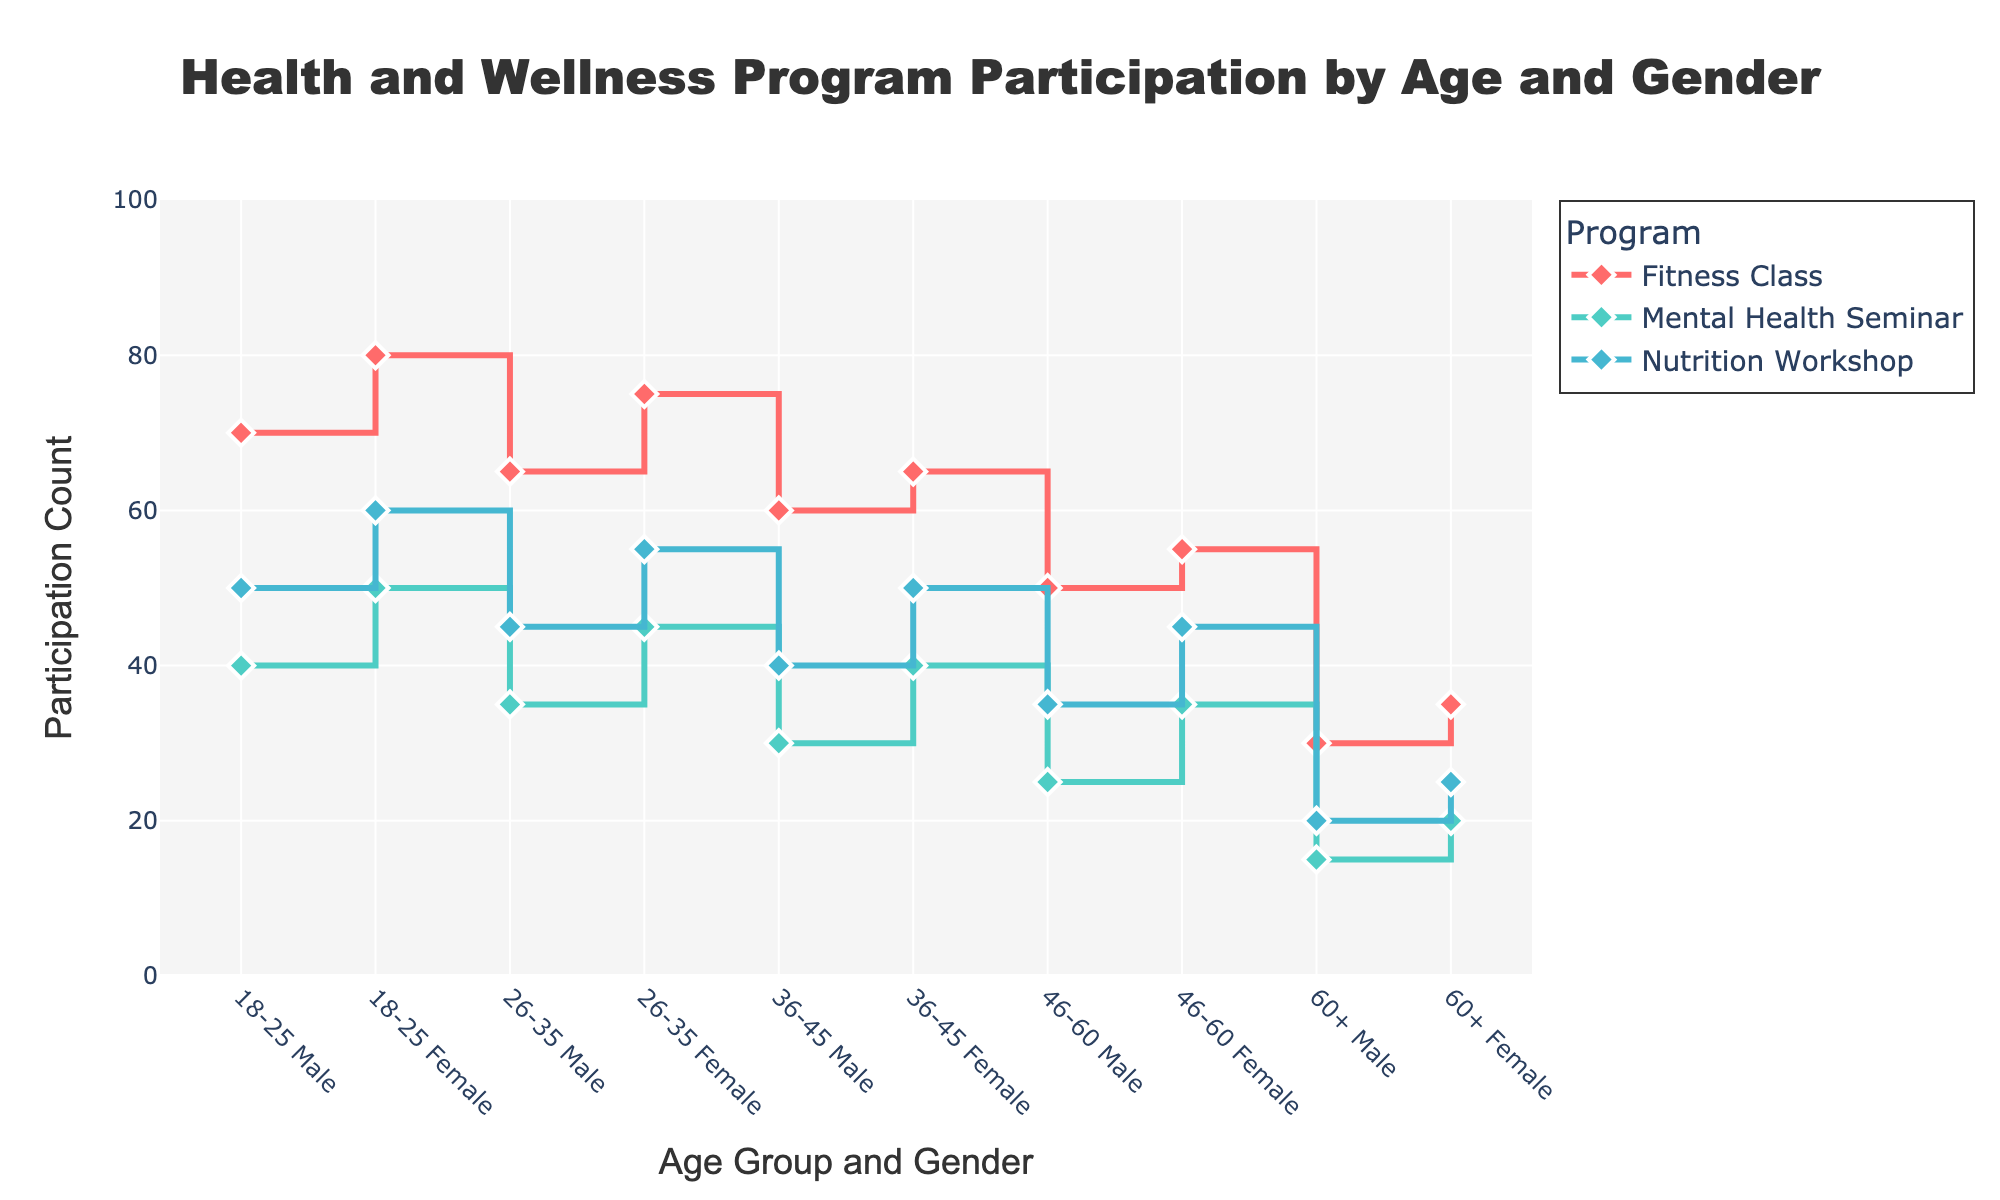What's the title of the figure? The title is located at the top of the figure in large text. It is "Health and Wellness Program Participation by Age and Gender".
Answer: Health and Wellness Program Participation by Age and Gender How many programs are represented in the figure? There are different traces/lines on the plot, with each line representing a program. There are three distinct lines, each labeled: 'Nutrition Workshop', 'Fitness Class', and 'Mental Health Seminar'.
Answer: 3 Which age and gender group has the highest participation in the 'Fitness Class'? Look at the line corresponding to the 'Fitness Class'. The highest point on this line is at '18-25 Female', showing the highest participation count.
Answer: 18-25 Female What is the participation count for the 'Mental Health Seminar' for the 36-45 age group, Female? Look at the line corresponding to 'Mental Health Seminar' and find the value for '36-45 Female'. The point on the line is at 40 participants.
Answer: 40 Compare the participation counts of 'Nutrition Workshop' for '18-25 Male' and '46-60 Female'. Which one is higher? Locate the points on the 'Nutrition Workshop' line for '18-25 Male' and '46-60 Female'. '18-25 Male' has 50 participants and '46-60 Female' has 45 participants. Thus, '18-25 Male' is higher.
Answer: 18-25 Male By how much does the participation count in 'Mental Health Seminar' for '18-25 Male' exceed '60+ Male'? Locate the 'Mental Health Seminar' points for '18-25 Male' and '60+ Male'. '18-25 Male' has 40 participants and '60+ Male' has 15 participants. The difference is 40 - 15 = 25.
Answer: 25 What is the average participation count for 'Fitness Class' across all age and gender groups? Sum all the participation counts for 'Fitness Class' (70+80+65+75+60+65+50+55+30+35 = 585) and divide by the number of groups (10). The average is 585 / 10 = 58.5.
Answer: 58.5 Which age group, irrespective of gender, shows a decreasing trend in participation for all programs? Observe the trend lines for each program. Only the 60+ age group shows a consistently lower participation count across Nutrition Workshop, Fitness Class, and Mental Health Seminar.
Answer: 60+ Between '26-35 Female' and '26-35 Male', which group has a more significant decrease in participation counts from 'Fitness Class' to 'Mental Health Seminar'? '26-35 Female' has 75 in Fitness Class and 45 in Mental Health Seminar (a decrease of 30), '26-35 Male' has 65 in Fitness Class and 35 in Mental Health Seminar (a decrease of 30). Both groups have the same decrease.
Answer: Both the same 